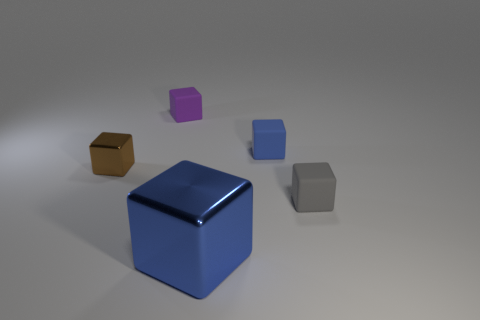Is there anything else that is the same size as the blue shiny cube?
Your response must be concise. No. How many matte things are brown objects or small blue blocks?
Offer a very short reply. 1. There is a brown block that is the same size as the purple matte object; what material is it?
Provide a succinct answer. Metal. Is there a tiny blue cube that has the same material as the tiny purple object?
Provide a succinct answer. Yes. Do the purple thing and the blue cube that is in front of the small blue object have the same size?
Your response must be concise. No. What number of tiny objects are either brown cubes or cubes?
Make the answer very short. 4. Are there an equal number of tiny purple blocks behind the tiny gray rubber block and large blue shiny objects that are on the left side of the tiny purple matte thing?
Your answer should be very brief. No. What number of other things are the same color as the large block?
Keep it short and to the point. 1. Are there an equal number of metallic things that are left of the big object and tiny red cylinders?
Offer a very short reply. No. Do the purple cube and the blue matte thing have the same size?
Give a very brief answer. Yes. 